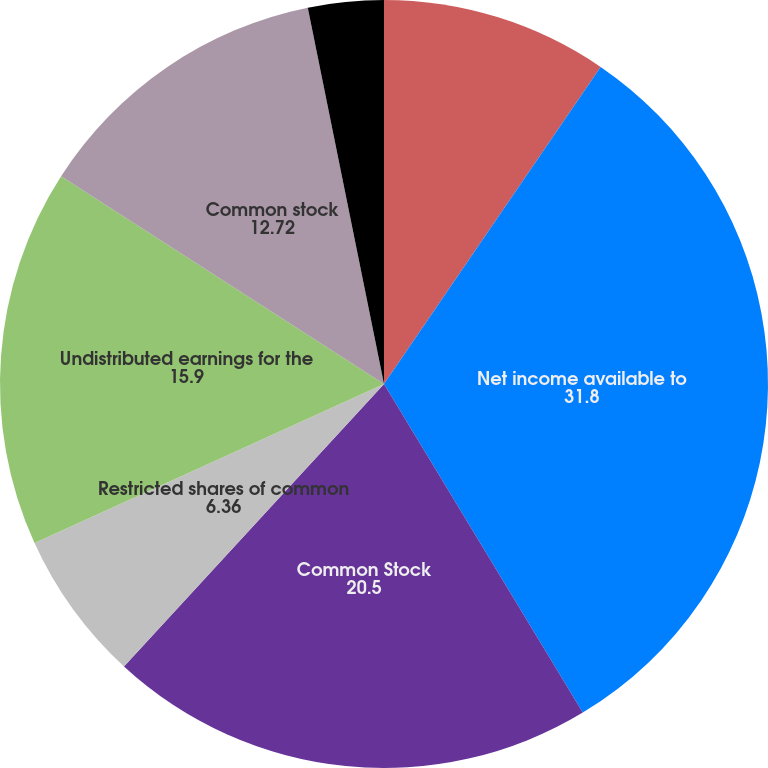Convert chart to OTSL. <chart><loc_0><loc_0><loc_500><loc_500><pie_chart><fcel>Years Ended December 31<fcel>Net income available to<fcel>Common Stock<fcel>Restricted shares of common<fcel>Undistributed earnings for the<fcel>Common stock<fcel>Distributed earnings<fcel>Undistributed earnings<nl><fcel>9.54%<fcel>31.8%<fcel>20.5%<fcel>6.36%<fcel>15.9%<fcel>12.72%<fcel>3.18%<fcel>0.0%<nl></chart> 